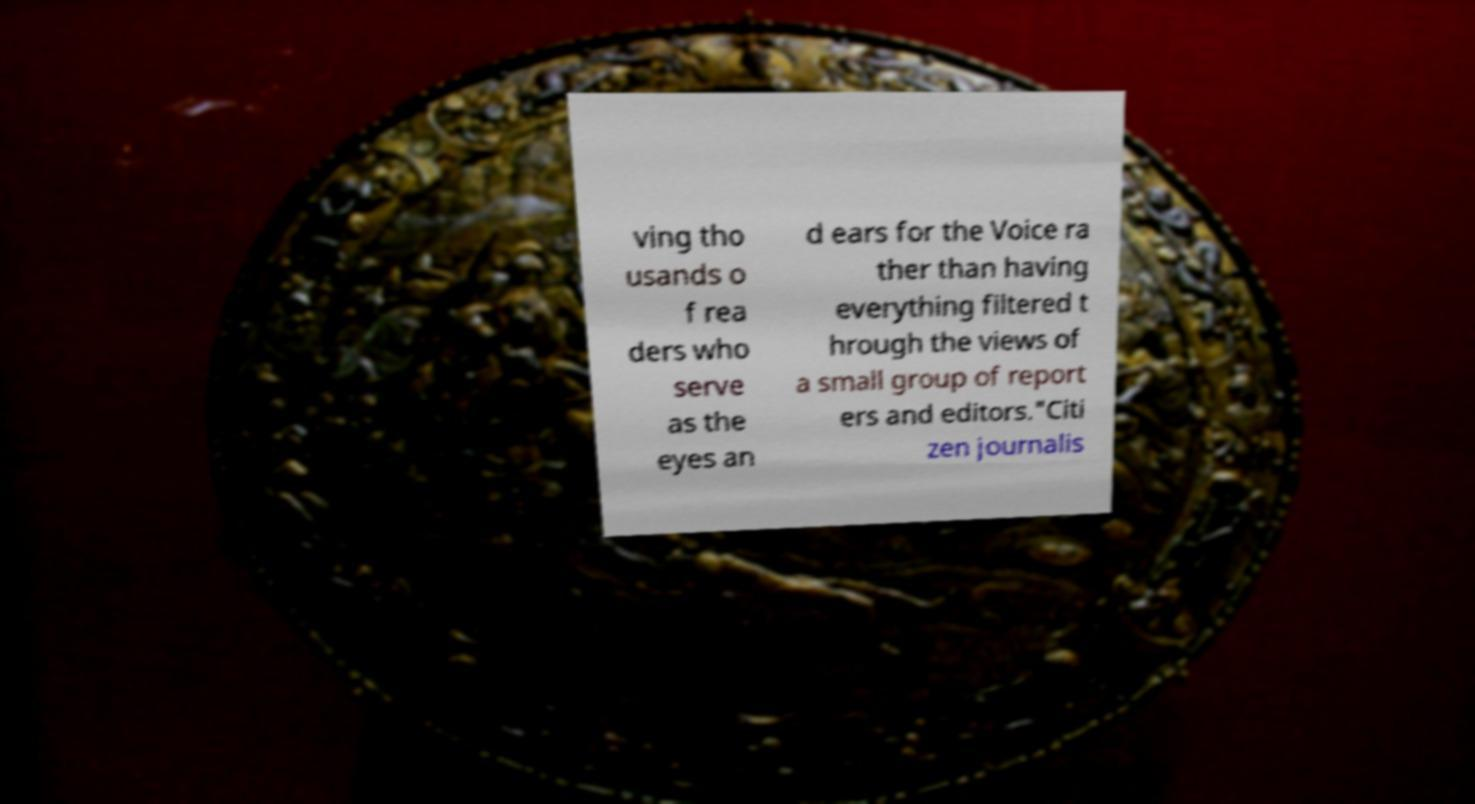There's text embedded in this image that I need extracted. Can you transcribe it verbatim? ving tho usands o f rea ders who serve as the eyes an d ears for the Voice ra ther than having everything filtered t hrough the views of a small group of report ers and editors."Citi zen journalis 